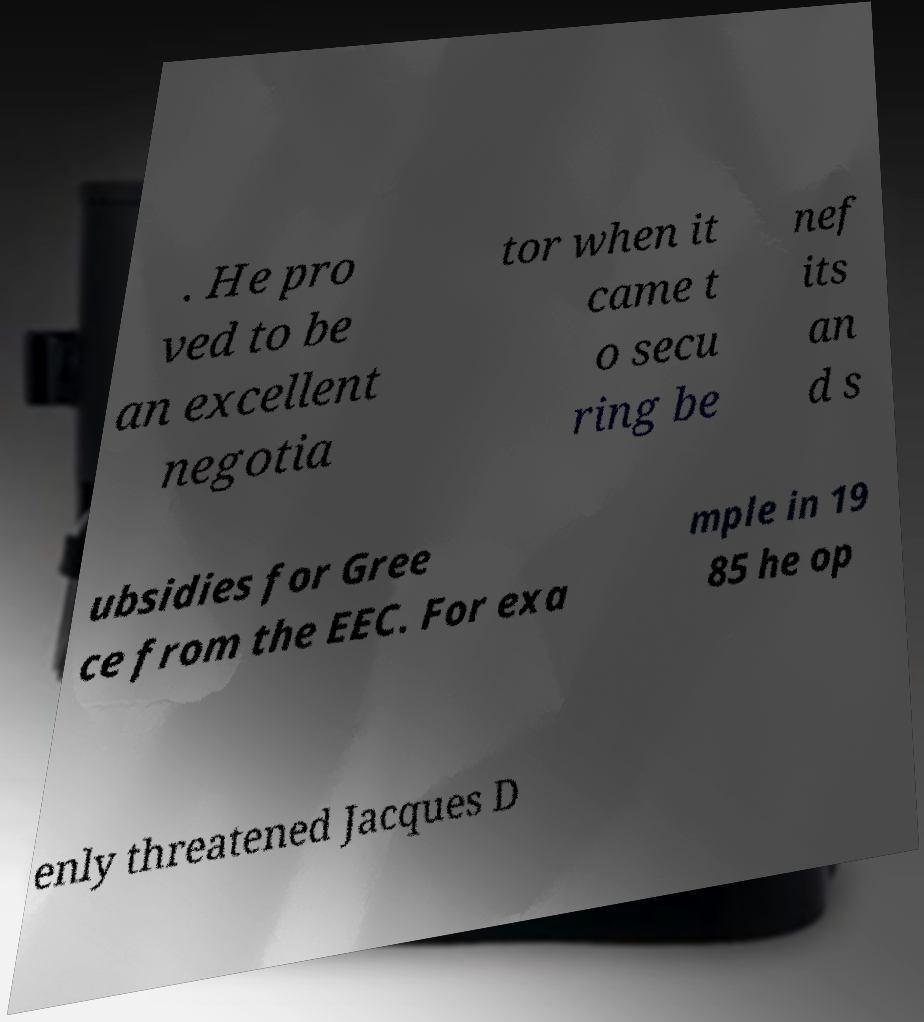What messages or text are displayed in this image? I need them in a readable, typed format. . He pro ved to be an excellent negotia tor when it came t o secu ring be nef its an d s ubsidies for Gree ce from the EEC. For exa mple in 19 85 he op enly threatened Jacques D 